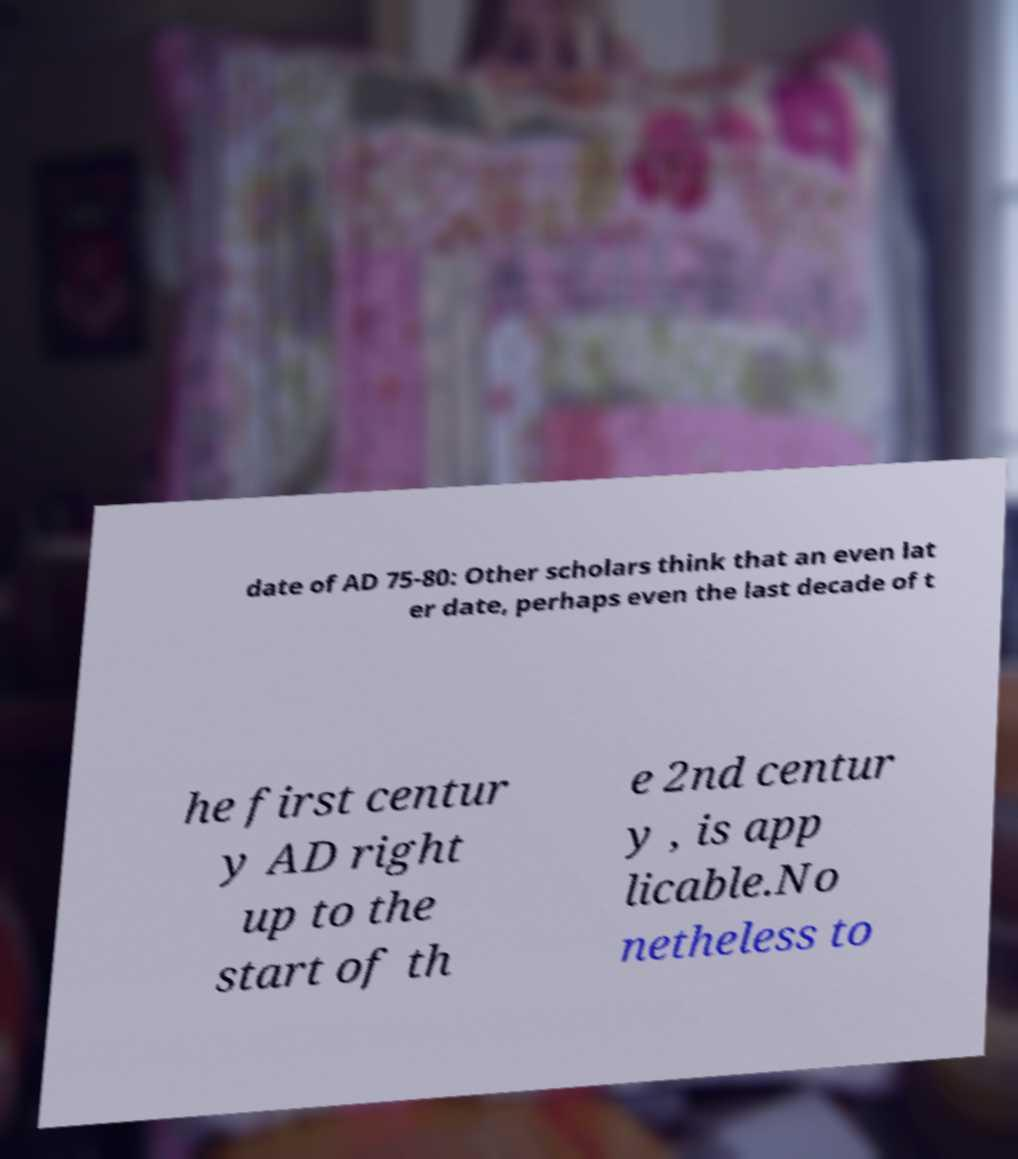Please read and relay the text visible in this image. What does it say? date of AD 75-80: Other scholars think that an even lat er date, perhaps even the last decade of t he first centur y AD right up to the start of th e 2nd centur y , is app licable.No netheless to 